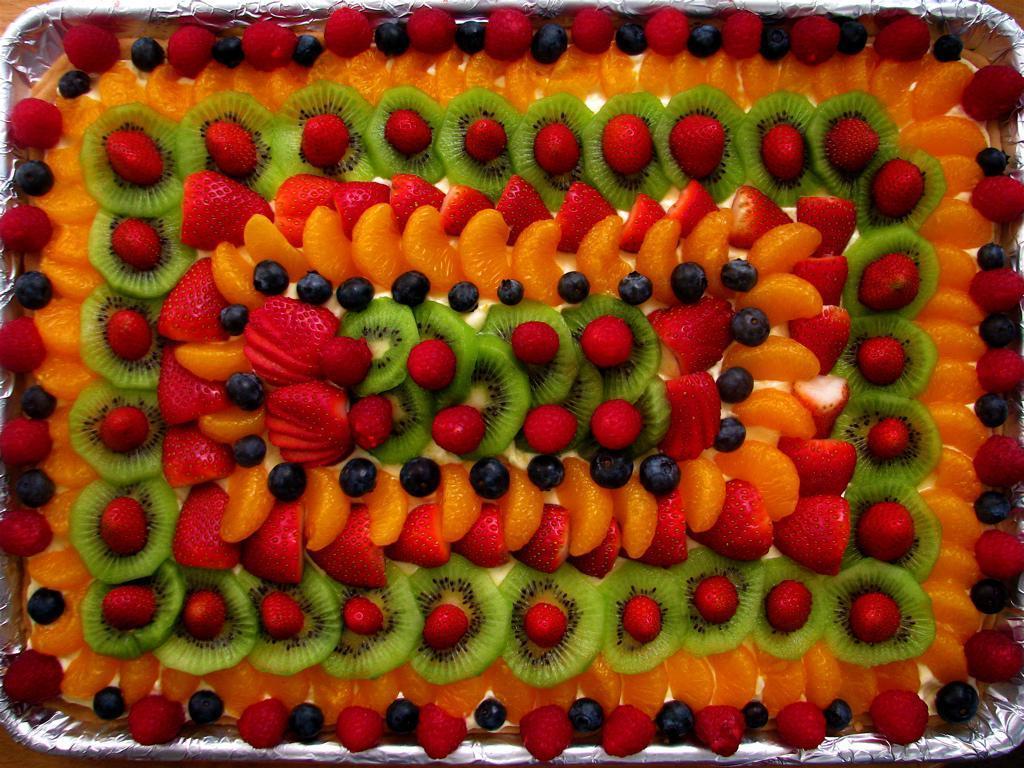How would you summarize this image in a sentence or two? In this image it looks like a cake decorated with fruits, strawberries. 